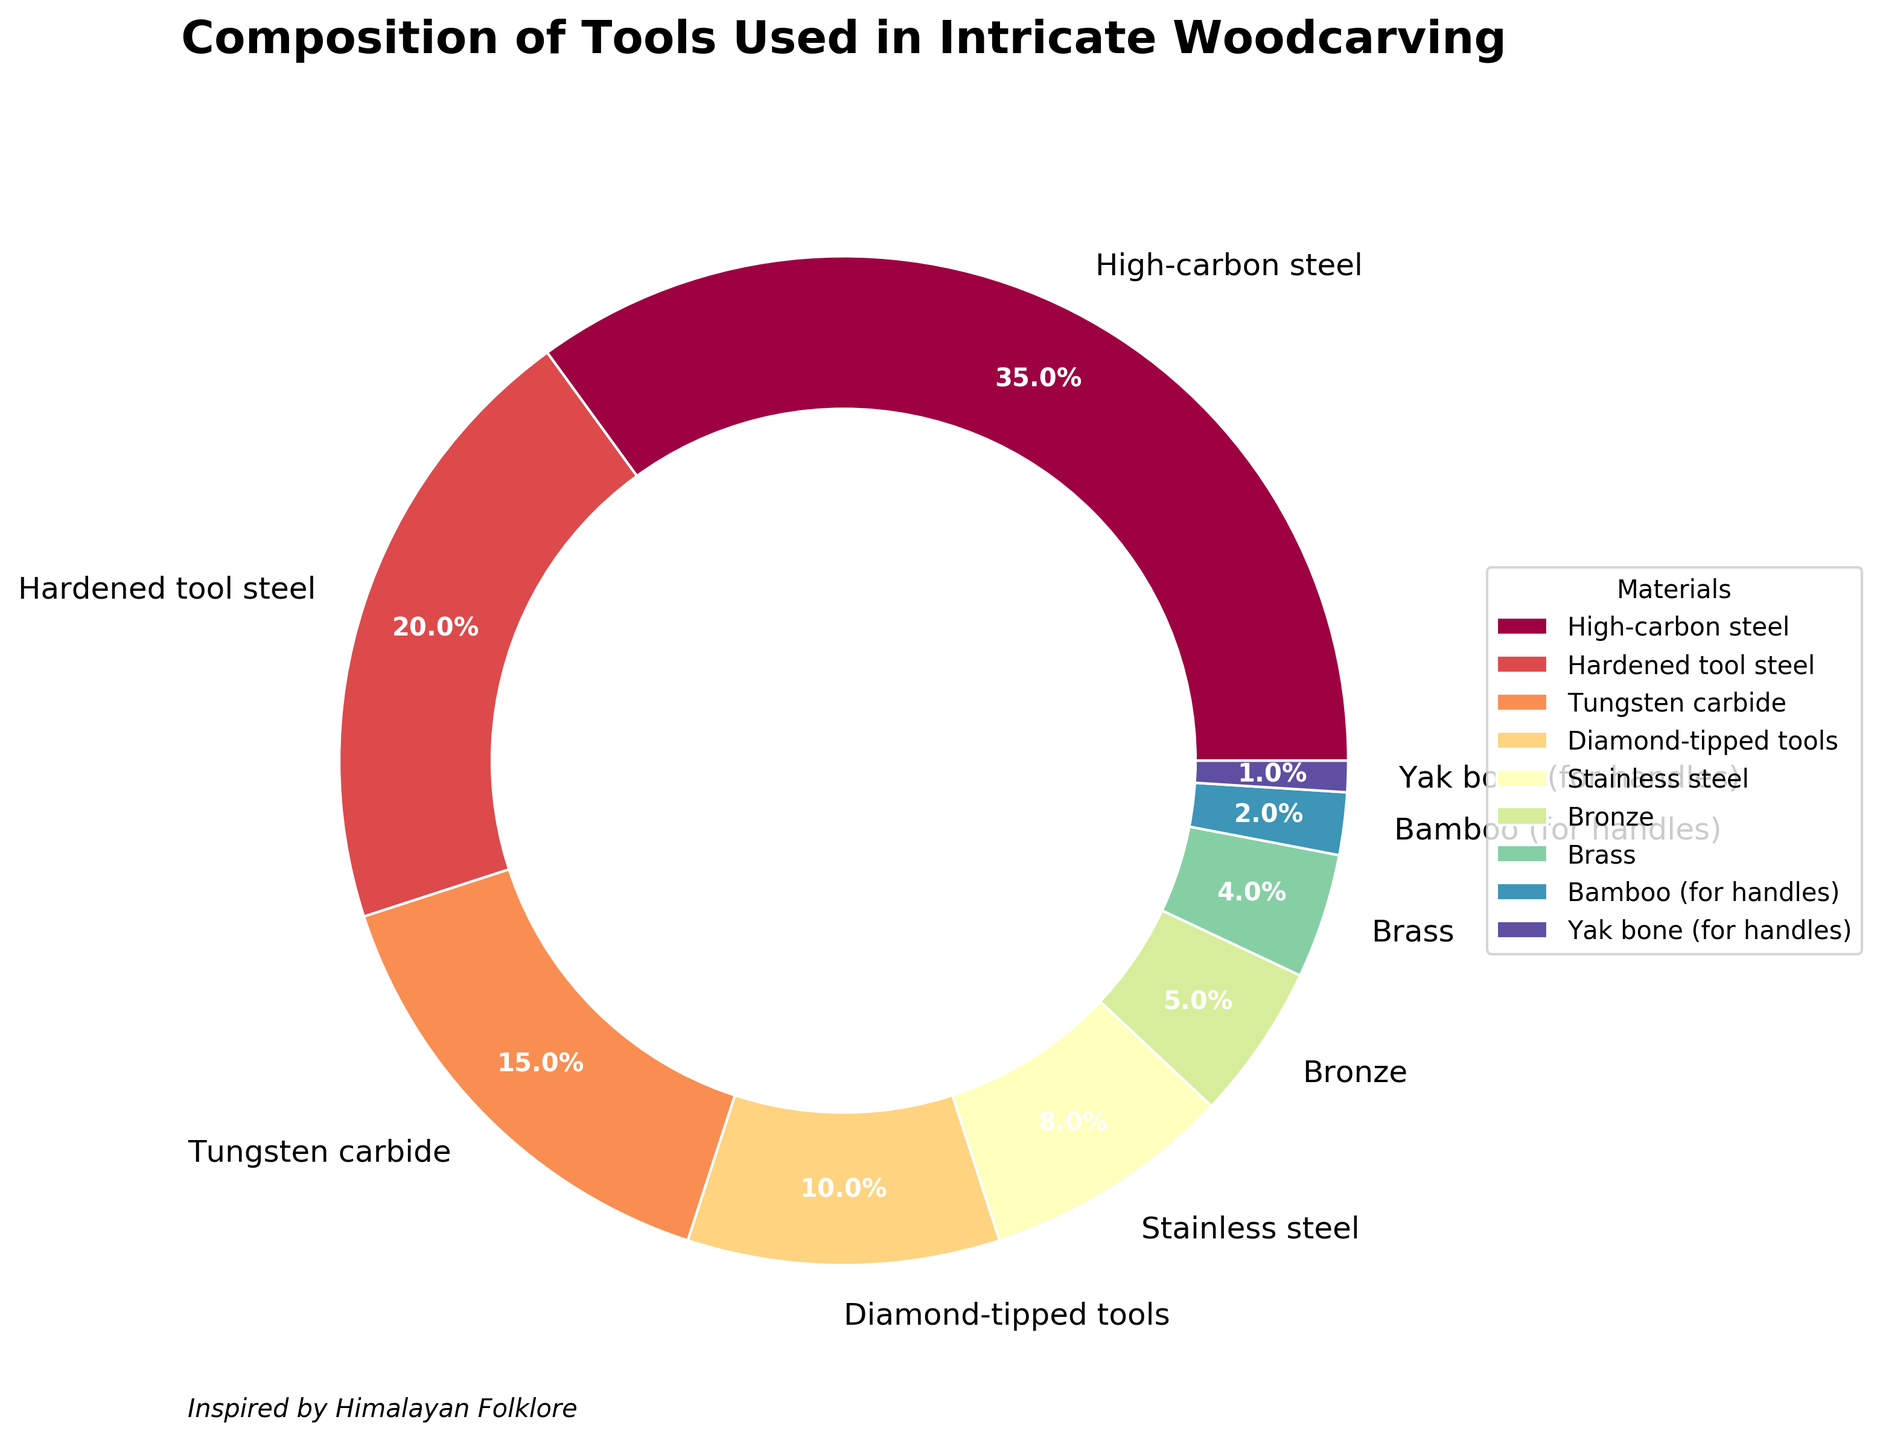Which material is used the most in intricate woodcarving tools? The figure shows that high-carbon steel has the largest portion of the pie chart.
Answer: High-carbon steel What is the total percentage of all the materials used for handles? Bamboo accounts for 2% and Yak bone accounts for 1%, so the total is 2% + 1% = 3%.
Answer: 3% How does the percentage of hardened tool steel compare to that of tungsten carbide? The percentage of hardened tool steel is 20%, while that of tungsten carbide is 15%. So, hardened tool steel is 5% higher.
Answer: Hardened tool steel is 5% higher Which materials make up less than 10% of the total? The materials with less than 10% are diamond-tipped tools (10%), stainless steel (8%), bronze (5%), brass (4%), bamboo (2%), and yak bone (1%).
Answer: Diamond-tipped tools, stainless steel, bronze, brass, bamboo, yak bone What is the combined percentage of high-carbon steel and stainless steel? High-carbon steel is 35% and stainless steel is 8%, so the combined percentage is 35% + 8% = 43%.
Answer: 43% What fraction of the tools are made from high-carbon steel, hardened tool steel, and tungsten carbide combined? High-carbon steel is 35%, hardened tool steel is 20%, and tungsten carbide is 15%. Combined, they constitute 35% + 20% + 15% = 70%, which is 70/100 or 7/10.
Answer: 7/10 How much higher is the percentage of tools made from high-carbon steel compared to those made from stainless steel? High-carbon steel is 35% and stainless steel is 8%, so the difference is 35% - 8% = 27%.
Answer: 27% Among the materials used, which one is used the least? The figure shows that Yak bone has the smallest portion of the pie chart.
Answer: Yak bone What is the difference in percentage between the most used and the least used material? The most used material is high-carbon steel at 35%, and the least used material is Yak bone at 1%. The difference is 35% - 1% = 34%.
Answer: 34% If you were to group the materials into two categories, "Metal" and "Non-metal," which category would have a higher percentage, and by how much? Metals (high-carbon steel, hardened tool steel, tungsten carbide, diamond-tipped tools, stainless steel, bronze, brass) total 97%. Non-metals (bamboo, yak bone) total 3%. The metal category is higher by 97% - 3% = 94%.
Answer: Metal, by 94% 